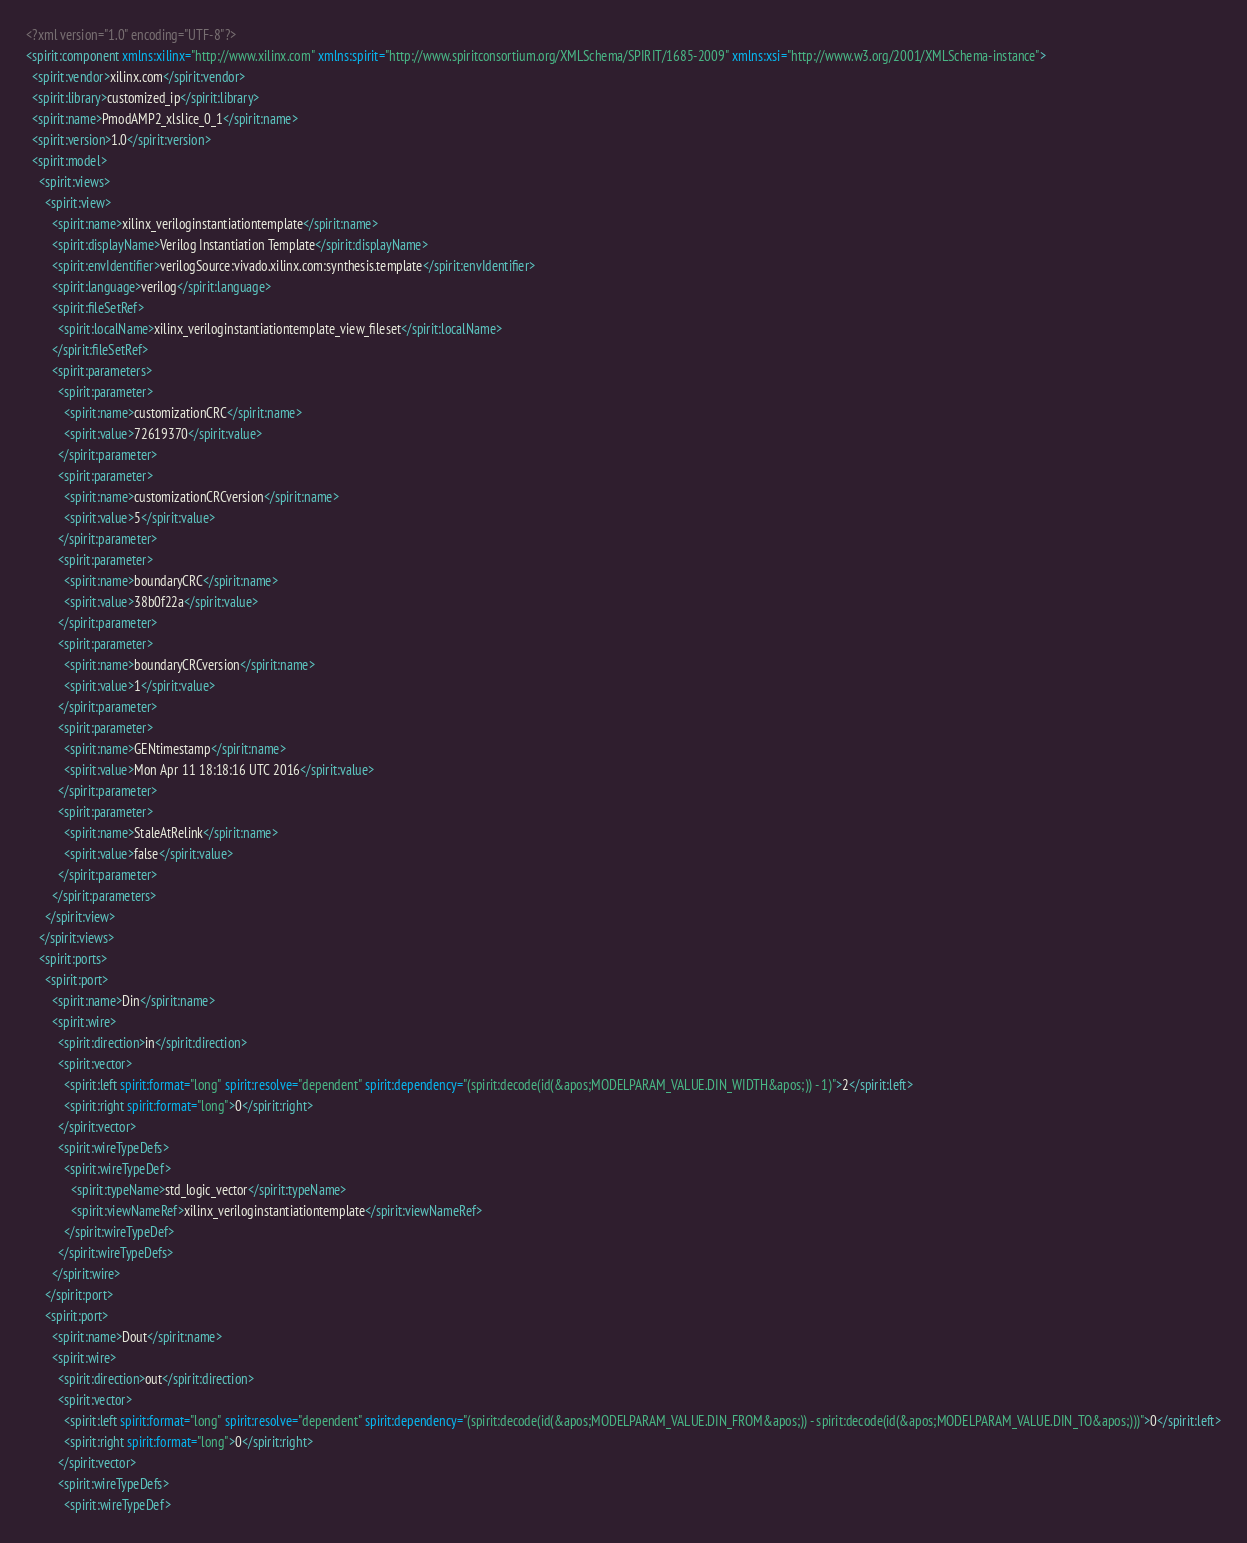<code> <loc_0><loc_0><loc_500><loc_500><_XML_><?xml version="1.0" encoding="UTF-8"?>
<spirit:component xmlns:xilinx="http://www.xilinx.com" xmlns:spirit="http://www.spiritconsortium.org/XMLSchema/SPIRIT/1685-2009" xmlns:xsi="http://www.w3.org/2001/XMLSchema-instance">
  <spirit:vendor>xilinx.com</spirit:vendor>
  <spirit:library>customized_ip</spirit:library>
  <spirit:name>PmodAMP2_xlslice_0_1</spirit:name>
  <spirit:version>1.0</spirit:version>
  <spirit:model>
    <spirit:views>
      <spirit:view>
        <spirit:name>xilinx_veriloginstantiationtemplate</spirit:name>
        <spirit:displayName>Verilog Instantiation Template</spirit:displayName>
        <spirit:envIdentifier>verilogSource:vivado.xilinx.com:synthesis.template</spirit:envIdentifier>
        <spirit:language>verilog</spirit:language>
        <spirit:fileSetRef>
          <spirit:localName>xilinx_veriloginstantiationtemplate_view_fileset</spirit:localName>
        </spirit:fileSetRef>
        <spirit:parameters>
          <spirit:parameter>
            <spirit:name>customizationCRC</spirit:name>
            <spirit:value>72619370</spirit:value>
          </spirit:parameter>
          <spirit:parameter>
            <spirit:name>customizationCRCversion</spirit:name>
            <spirit:value>5</spirit:value>
          </spirit:parameter>
          <spirit:parameter>
            <spirit:name>boundaryCRC</spirit:name>
            <spirit:value>38b0f22a</spirit:value>
          </spirit:parameter>
          <spirit:parameter>
            <spirit:name>boundaryCRCversion</spirit:name>
            <spirit:value>1</spirit:value>
          </spirit:parameter>
          <spirit:parameter>
            <spirit:name>GENtimestamp</spirit:name>
            <spirit:value>Mon Apr 11 18:18:16 UTC 2016</spirit:value>
          </spirit:parameter>
          <spirit:parameter>
            <spirit:name>StaleAtRelink</spirit:name>
            <spirit:value>false</spirit:value>
          </spirit:parameter>
        </spirit:parameters>
      </spirit:view>
    </spirit:views>
    <spirit:ports>
      <spirit:port>
        <spirit:name>Din</spirit:name>
        <spirit:wire>
          <spirit:direction>in</spirit:direction>
          <spirit:vector>
            <spirit:left spirit:format="long" spirit:resolve="dependent" spirit:dependency="(spirit:decode(id(&apos;MODELPARAM_VALUE.DIN_WIDTH&apos;)) - 1)">2</spirit:left>
            <spirit:right spirit:format="long">0</spirit:right>
          </spirit:vector>
          <spirit:wireTypeDefs>
            <spirit:wireTypeDef>
              <spirit:typeName>std_logic_vector</spirit:typeName>
              <spirit:viewNameRef>xilinx_veriloginstantiationtemplate</spirit:viewNameRef>
            </spirit:wireTypeDef>
          </spirit:wireTypeDefs>
        </spirit:wire>
      </spirit:port>
      <spirit:port>
        <spirit:name>Dout</spirit:name>
        <spirit:wire>
          <spirit:direction>out</spirit:direction>
          <spirit:vector>
            <spirit:left spirit:format="long" spirit:resolve="dependent" spirit:dependency="(spirit:decode(id(&apos;MODELPARAM_VALUE.DIN_FROM&apos;)) - spirit:decode(id(&apos;MODELPARAM_VALUE.DIN_TO&apos;)))">0</spirit:left>
            <spirit:right spirit:format="long">0</spirit:right>
          </spirit:vector>
          <spirit:wireTypeDefs>
            <spirit:wireTypeDef></code> 